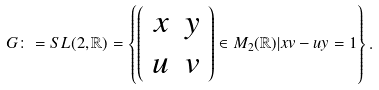<formula> <loc_0><loc_0><loc_500><loc_500>G \colon = S L ( 2 , \mathbb { R } ) = \left \{ \left ( \begin{array} { c c } x & y \\ u & v \end{array} \right ) \in M _ { 2 } ( \mathbb { R } ) | x v - u y = 1 \right \} .</formula> 